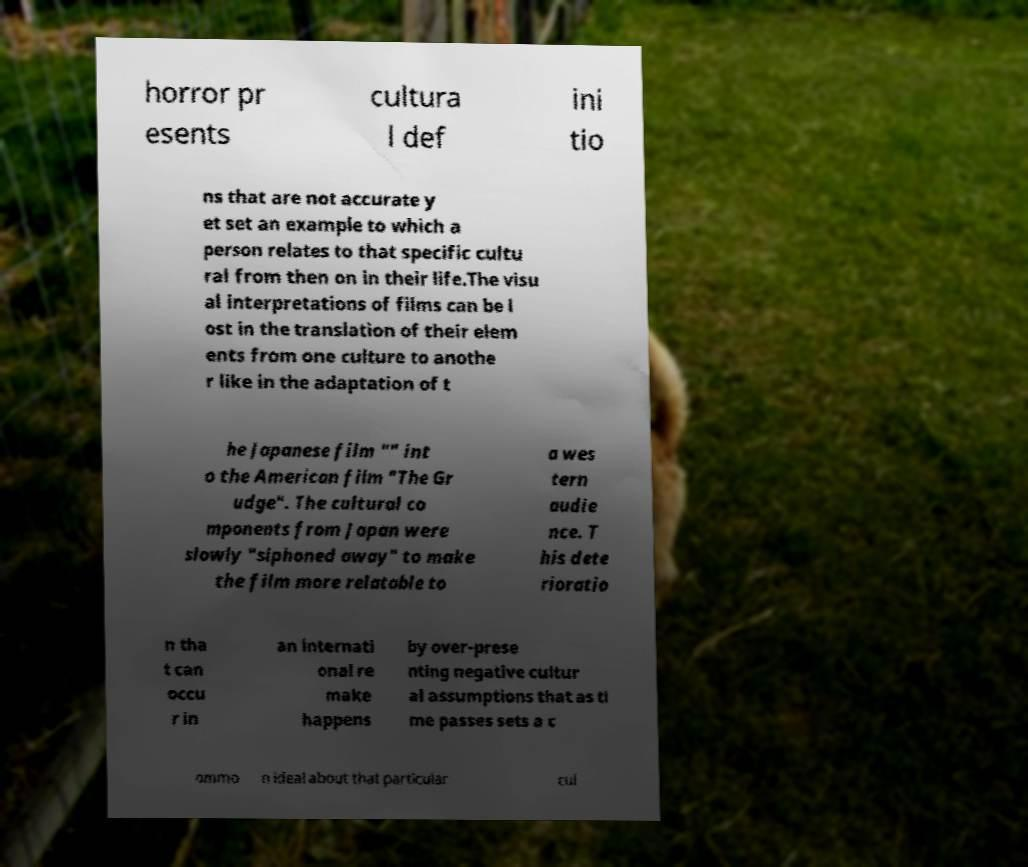Could you extract and type out the text from this image? horror pr esents cultura l def ini tio ns that are not accurate y et set an example to which a person relates to that specific cultu ral from then on in their life.The visu al interpretations of films can be l ost in the translation of their elem ents from one culture to anothe r like in the adaptation of t he Japanese film "" int o the American film "The Gr udge". The cultural co mponents from Japan were slowly "siphoned away" to make the film more relatable to a wes tern audie nce. T his dete rioratio n tha t can occu r in an internati onal re make happens by over-prese nting negative cultur al assumptions that as ti me passes sets a c ommo n ideal about that particular cul 